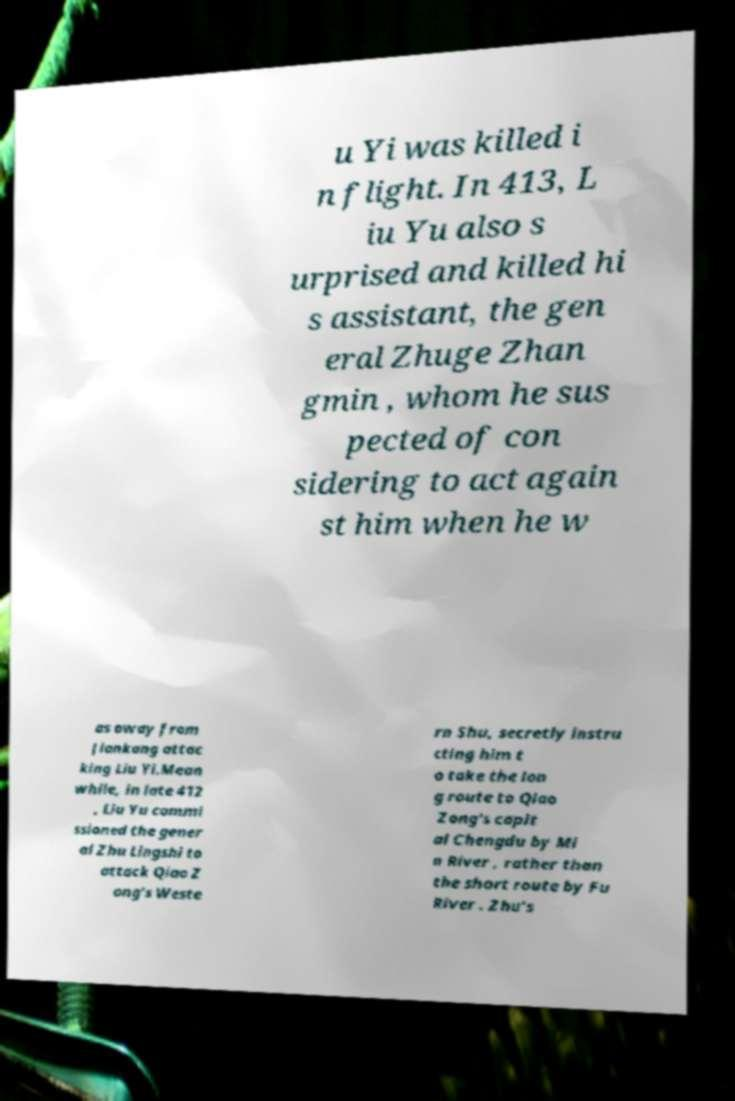Can you read and provide the text displayed in the image?This photo seems to have some interesting text. Can you extract and type it out for me? u Yi was killed i n flight. In 413, L iu Yu also s urprised and killed hi s assistant, the gen eral Zhuge Zhan gmin , whom he sus pected of con sidering to act again st him when he w as away from Jiankang attac king Liu Yi.Mean while, in late 412 , Liu Yu commi ssioned the gener al Zhu Lingshi to attack Qiao Z ong's Weste rn Shu, secretly instru cting him t o take the lon g route to Qiao Zong's capit al Chengdu by Mi n River , rather than the short route by Fu River . Zhu's 